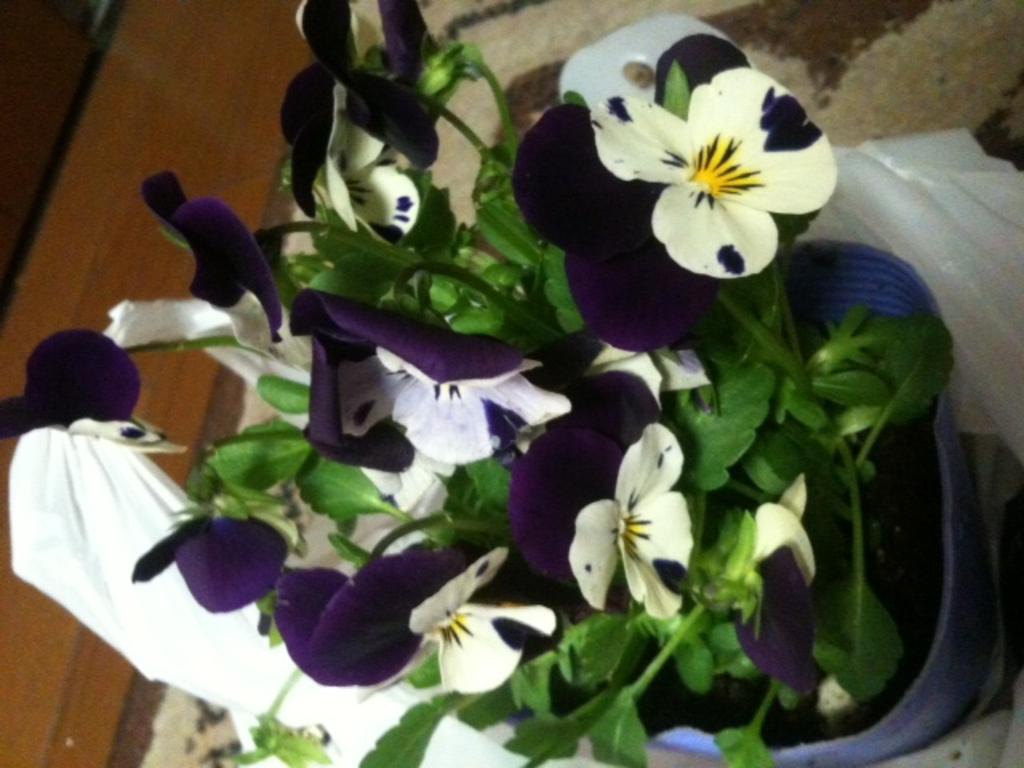Can you describe this image briefly? In this image there is a flower vase placed on the stand. In the background there is a cloth. On the left there is a wooden block. 